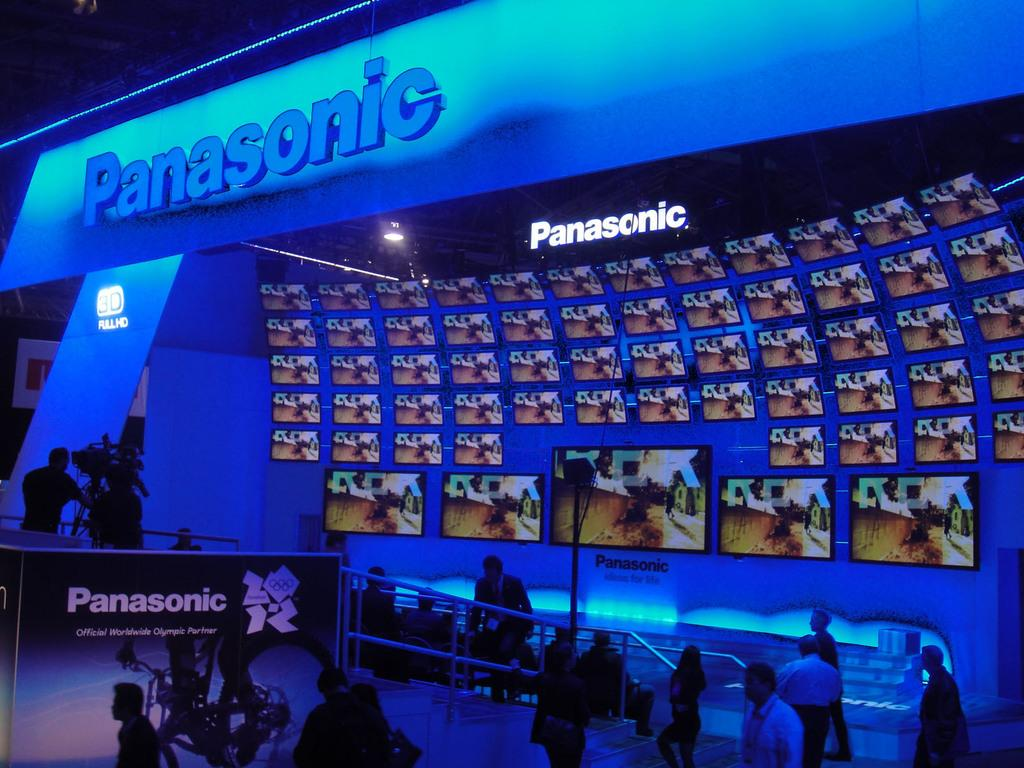What type of structure can be seen in the image? There is a wall in the image. What device is present in the image? There is a camera in the image. What type of display devices are visible in the image? There are screens in the image. What type of signage is present in the image? There are banners in the image. Can you describe the people in the image? There are people in the image. What type of voyage is the woman embarking on in the image? There is no woman present in the image, and therefore no voyage can be observed. What type of plane is visible in the image? There is no plane present in the image. 